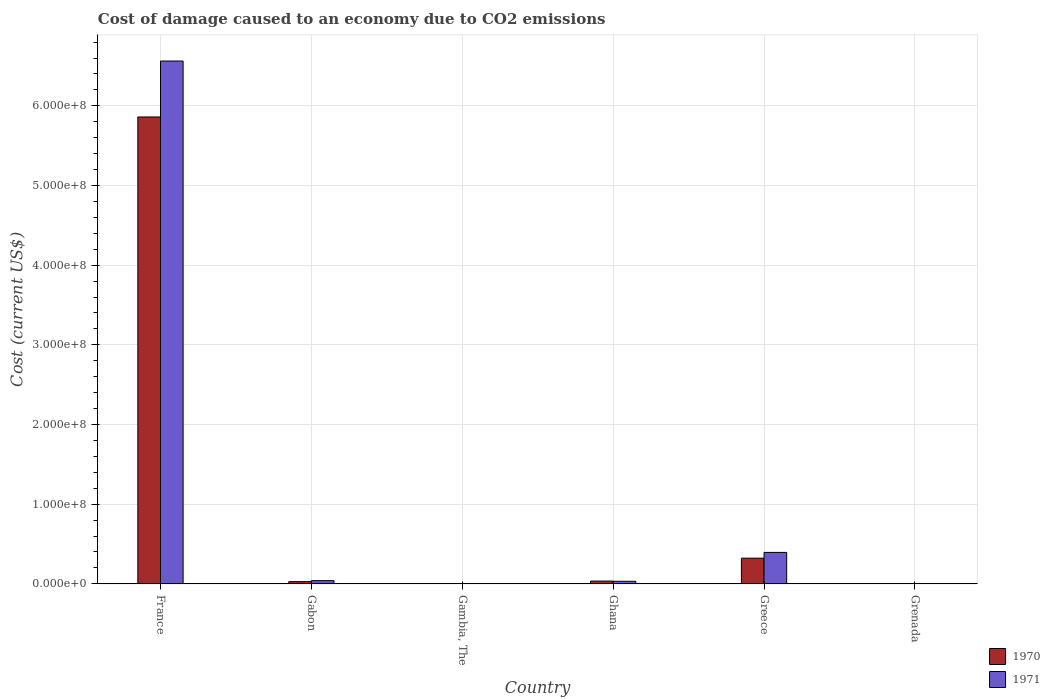How many groups of bars are there?
Provide a succinct answer. 6. Are the number of bars per tick equal to the number of legend labels?
Your answer should be compact. Yes. Are the number of bars on each tick of the X-axis equal?
Provide a succinct answer. Yes. What is the label of the 6th group of bars from the left?
Ensure brevity in your answer.  Grenada. What is the cost of damage caused due to CO2 emissisons in 1971 in France?
Your answer should be compact. 6.56e+08. Across all countries, what is the maximum cost of damage caused due to CO2 emissisons in 1970?
Give a very brief answer. 5.86e+08. Across all countries, what is the minimum cost of damage caused due to CO2 emissisons in 1970?
Your answer should be compact. 5.87e+04. In which country was the cost of damage caused due to CO2 emissisons in 1970 minimum?
Provide a short and direct response. Grenada. What is the total cost of damage caused due to CO2 emissisons in 1971 in the graph?
Provide a succinct answer. 7.03e+08. What is the difference between the cost of damage caused due to CO2 emissisons in 1971 in Greece and that in Grenada?
Provide a short and direct response. 3.94e+07. What is the difference between the cost of damage caused due to CO2 emissisons in 1971 in France and the cost of damage caused due to CO2 emissisons in 1970 in Greece?
Offer a terse response. 6.24e+08. What is the average cost of damage caused due to CO2 emissisons in 1971 per country?
Your answer should be very brief. 1.17e+08. What is the difference between the cost of damage caused due to CO2 emissisons of/in 1970 and cost of damage caused due to CO2 emissisons of/in 1971 in Gabon?
Make the answer very short. -1.26e+06. What is the ratio of the cost of damage caused due to CO2 emissisons in 1970 in Gabon to that in Grenada?
Your response must be concise. 47.33. Is the cost of damage caused due to CO2 emissisons in 1971 in Gabon less than that in Greece?
Ensure brevity in your answer.  Yes. Is the difference between the cost of damage caused due to CO2 emissisons in 1970 in France and Gabon greater than the difference between the cost of damage caused due to CO2 emissisons in 1971 in France and Gabon?
Give a very brief answer. No. What is the difference between the highest and the second highest cost of damage caused due to CO2 emissisons in 1970?
Keep it short and to the point. -5.54e+08. What is the difference between the highest and the lowest cost of damage caused due to CO2 emissisons in 1971?
Provide a succinct answer. 6.56e+08. In how many countries, is the cost of damage caused due to CO2 emissisons in 1971 greater than the average cost of damage caused due to CO2 emissisons in 1971 taken over all countries?
Keep it short and to the point. 1. What does the 1st bar from the left in Gambia, The represents?
Offer a terse response. 1970. What does the 1st bar from the right in Greece represents?
Make the answer very short. 1971. How many bars are there?
Your answer should be compact. 12. How many countries are there in the graph?
Your answer should be very brief. 6. Are the values on the major ticks of Y-axis written in scientific E-notation?
Offer a terse response. Yes. Where does the legend appear in the graph?
Make the answer very short. Bottom right. How many legend labels are there?
Your answer should be very brief. 2. How are the legend labels stacked?
Your response must be concise. Vertical. What is the title of the graph?
Make the answer very short. Cost of damage caused to an economy due to CO2 emissions. Does "1978" appear as one of the legend labels in the graph?
Your response must be concise. No. What is the label or title of the X-axis?
Provide a short and direct response. Country. What is the label or title of the Y-axis?
Provide a succinct answer. Cost (current US$). What is the Cost (current US$) of 1970 in France?
Offer a very short reply. 5.86e+08. What is the Cost (current US$) of 1971 in France?
Your answer should be compact. 6.56e+08. What is the Cost (current US$) in 1970 in Gabon?
Your response must be concise. 2.78e+06. What is the Cost (current US$) in 1971 in Gabon?
Offer a very short reply. 4.04e+06. What is the Cost (current US$) of 1970 in Gambia, The?
Provide a short and direct response. 6.36e+04. What is the Cost (current US$) in 1971 in Gambia, The?
Give a very brief answer. 7.81e+04. What is the Cost (current US$) in 1970 in Ghana?
Keep it short and to the point. 3.50e+06. What is the Cost (current US$) in 1971 in Ghana?
Your answer should be compact. 3.26e+06. What is the Cost (current US$) of 1970 in Greece?
Your response must be concise. 3.23e+07. What is the Cost (current US$) in 1971 in Greece?
Your answer should be compact. 3.95e+07. What is the Cost (current US$) of 1970 in Grenada?
Ensure brevity in your answer.  5.87e+04. What is the Cost (current US$) of 1971 in Grenada?
Your answer should be compact. 6.76e+04. Across all countries, what is the maximum Cost (current US$) of 1970?
Offer a very short reply. 5.86e+08. Across all countries, what is the maximum Cost (current US$) in 1971?
Provide a succinct answer. 6.56e+08. Across all countries, what is the minimum Cost (current US$) in 1970?
Provide a succinct answer. 5.87e+04. Across all countries, what is the minimum Cost (current US$) in 1971?
Offer a terse response. 6.76e+04. What is the total Cost (current US$) of 1970 in the graph?
Give a very brief answer. 6.25e+08. What is the total Cost (current US$) of 1971 in the graph?
Give a very brief answer. 7.03e+08. What is the difference between the Cost (current US$) in 1970 in France and that in Gabon?
Offer a terse response. 5.83e+08. What is the difference between the Cost (current US$) in 1971 in France and that in Gabon?
Offer a very short reply. 6.52e+08. What is the difference between the Cost (current US$) in 1970 in France and that in Gambia, The?
Your answer should be very brief. 5.86e+08. What is the difference between the Cost (current US$) in 1971 in France and that in Gambia, The?
Provide a short and direct response. 6.56e+08. What is the difference between the Cost (current US$) of 1970 in France and that in Ghana?
Ensure brevity in your answer.  5.82e+08. What is the difference between the Cost (current US$) in 1971 in France and that in Ghana?
Provide a succinct answer. 6.53e+08. What is the difference between the Cost (current US$) of 1970 in France and that in Greece?
Offer a very short reply. 5.54e+08. What is the difference between the Cost (current US$) of 1971 in France and that in Greece?
Offer a terse response. 6.17e+08. What is the difference between the Cost (current US$) of 1970 in France and that in Grenada?
Your answer should be very brief. 5.86e+08. What is the difference between the Cost (current US$) in 1971 in France and that in Grenada?
Make the answer very short. 6.56e+08. What is the difference between the Cost (current US$) of 1970 in Gabon and that in Gambia, The?
Your answer should be very brief. 2.72e+06. What is the difference between the Cost (current US$) of 1971 in Gabon and that in Gambia, The?
Provide a succinct answer. 3.96e+06. What is the difference between the Cost (current US$) in 1970 in Gabon and that in Ghana?
Make the answer very short. -7.24e+05. What is the difference between the Cost (current US$) of 1971 in Gabon and that in Ghana?
Keep it short and to the point. 7.81e+05. What is the difference between the Cost (current US$) in 1970 in Gabon and that in Greece?
Make the answer very short. -2.95e+07. What is the difference between the Cost (current US$) of 1971 in Gabon and that in Greece?
Ensure brevity in your answer.  -3.54e+07. What is the difference between the Cost (current US$) in 1970 in Gabon and that in Grenada?
Offer a very short reply. 2.72e+06. What is the difference between the Cost (current US$) of 1971 in Gabon and that in Grenada?
Give a very brief answer. 3.97e+06. What is the difference between the Cost (current US$) of 1970 in Gambia, The and that in Ghana?
Your answer should be very brief. -3.44e+06. What is the difference between the Cost (current US$) in 1971 in Gambia, The and that in Ghana?
Offer a very short reply. -3.18e+06. What is the difference between the Cost (current US$) of 1970 in Gambia, The and that in Greece?
Your answer should be very brief. -3.22e+07. What is the difference between the Cost (current US$) of 1971 in Gambia, The and that in Greece?
Give a very brief answer. -3.94e+07. What is the difference between the Cost (current US$) of 1970 in Gambia, The and that in Grenada?
Give a very brief answer. 4894.68. What is the difference between the Cost (current US$) in 1971 in Gambia, The and that in Grenada?
Your answer should be compact. 1.04e+04. What is the difference between the Cost (current US$) of 1970 in Ghana and that in Greece?
Your answer should be very brief. -2.88e+07. What is the difference between the Cost (current US$) of 1971 in Ghana and that in Greece?
Give a very brief answer. -3.62e+07. What is the difference between the Cost (current US$) in 1970 in Ghana and that in Grenada?
Give a very brief answer. 3.45e+06. What is the difference between the Cost (current US$) in 1971 in Ghana and that in Grenada?
Offer a very short reply. 3.19e+06. What is the difference between the Cost (current US$) in 1970 in Greece and that in Grenada?
Your answer should be compact. 3.22e+07. What is the difference between the Cost (current US$) in 1971 in Greece and that in Grenada?
Your answer should be compact. 3.94e+07. What is the difference between the Cost (current US$) in 1970 in France and the Cost (current US$) in 1971 in Gabon?
Provide a short and direct response. 5.82e+08. What is the difference between the Cost (current US$) of 1970 in France and the Cost (current US$) of 1971 in Gambia, The?
Provide a succinct answer. 5.86e+08. What is the difference between the Cost (current US$) of 1970 in France and the Cost (current US$) of 1971 in Ghana?
Give a very brief answer. 5.83e+08. What is the difference between the Cost (current US$) in 1970 in France and the Cost (current US$) in 1971 in Greece?
Make the answer very short. 5.47e+08. What is the difference between the Cost (current US$) of 1970 in France and the Cost (current US$) of 1971 in Grenada?
Make the answer very short. 5.86e+08. What is the difference between the Cost (current US$) in 1970 in Gabon and the Cost (current US$) in 1971 in Gambia, The?
Ensure brevity in your answer.  2.70e+06. What is the difference between the Cost (current US$) in 1970 in Gabon and the Cost (current US$) in 1971 in Ghana?
Provide a succinct answer. -4.77e+05. What is the difference between the Cost (current US$) in 1970 in Gabon and the Cost (current US$) in 1971 in Greece?
Offer a terse response. -3.67e+07. What is the difference between the Cost (current US$) in 1970 in Gabon and the Cost (current US$) in 1971 in Grenada?
Give a very brief answer. 2.71e+06. What is the difference between the Cost (current US$) of 1970 in Gambia, The and the Cost (current US$) of 1971 in Ghana?
Make the answer very short. -3.19e+06. What is the difference between the Cost (current US$) of 1970 in Gambia, The and the Cost (current US$) of 1971 in Greece?
Keep it short and to the point. -3.94e+07. What is the difference between the Cost (current US$) of 1970 in Gambia, The and the Cost (current US$) of 1971 in Grenada?
Make the answer very short. -4016.81. What is the difference between the Cost (current US$) of 1970 in Ghana and the Cost (current US$) of 1971 in Greece?
Make the answer very short. -3.60e+07. What is the difference between the Cost (current US$) in 1970 in Ghana and the Cost (current US$) in 1971 in Grenada?
Your response must be concise. 3.44e+06. What is the difference between the Cost (current US$) of 1970 in Greece and the Cost (current US$) of 1971 in Grenada?
Offer a very short reply. 3.22e+07. What is the average Cost (current US$) of 1970 per country?
Offer a terse response. 1.04e+08. What is the average Cost (current US$) of 1971 per country?
Offer a very short reply. 1.17e+08. What is the difference between the Cost (current US$) in 1970 and Cost (current US$) in 1971 in France?
Keep it short and to the point. -7.02e+07. What is the difference between the Cost (current US$) of 1970 and Cost (current US$) of 1971 in Gabon?
Offer a terse response. -1.26e+06. What is the difference between the Cost (current US$) in 1970 and Cost (current US$) in 1971 in Gambia, The?
Your response must be concise. -1.44e+04. What is the difference between the Cost (current US$) in 1970 and Cost (current US$) in 1971 in Ghana?
Give a very brief answer. 2.47e+05. What is the difference between the Cost (current US$) in 1970 and Cost (current US$) in 1971 in Greece?
Provide a succinct answer. -7.21e+06. What is the difference between the Cost (current US$) in 1970 and Cost (current US$) in 1971 in Grenada?
Your answer should be very brief. -8911.49. What is the ratio of the Cost (current US$) of 1970 in France to that in Gabon?
Your answer should be compact. 210.77. What is the ratio of the Cost (current US$) of 1971 in France to that in Gabon?
Offer a terse response. 162.51. What is the ratio of the Cost (current US$) in 1970 in France to that in Gambia, The?
Keep it short and to the point. 9209.23. What is the ratio of the Cost (current US$) in 1971 in France to that in Gambia, The?
Make the answer very short. 8407.13. What is the ratio of the Cost (current US$) in 1970 in France to that in Ghana?
Provide a short and direct response. 167.21. What is the ratio of the Cost (current US$) of 1971 in France to that in Ghana?
Ensure brevity in your answer.  201.45. What is the ratio of the Cost (current US$) in 1970 in France to that in Greece?
Give a very brief answer. 18.17. What is the ratio of the Cost (current US$) of 1971 in France to that in Greece?
Your response must be concise. 16.63. What is the ratio of the Cost (current US$) of 1970 in France to that in Grenada?
Your answer should be very brief. 9976.67. What is the ratio of the Cost (current US$) of 1971 in France to that in Grenada?
Provide a succinct answer. 9700.54. What is the ratio of the Cost (current US$) in 1970 in Gabon to that in Gambia, The?
Make the answer very short. 43.69. What is the ratio of the Cost (current US$) in 1971 in Gabon to that in Gambia, The?
Your response must be concise. 51.73. What is the ratio of the Cost (current US$) of 1970 in Gabon to that in Ghana?
Offer a terse response. 0.79. What is the ratio of the Cost (current US$) in 1971 in Gabon to that in Ghana?
Your answer should be compact. 1.24. What is the ratio of the Cost (current US$) in 1970 in Gabon to that in Greece?
Keep it short and to the point. 0.09. What is the ratio of the Cost (current US$) in 1971 in Gabon to that in Greece?
Make the answer very short. 0.1. What is the ratio of the Cost (current US$) in 1970 in Gabon to that in Grenada?
Your answer should be compact. 47.33. What is the ratio of the Cost (current US$) of 1971 in Gabon to that in Grenada?
Provide a succinct answer. 59.69. What is the ratio of the Cost (current US$) in 1970 in Gambia, The to that in Ghana?
Provide a succinct answer. 0.02. What is the ratio of the Cost (current US$) in 1971 in Gambia, The to that in Ghana?
Ensure brevity in your answer.  0.02. What is the ratio of the Cost (current US$) in 1970 in Gambia, The to that in Greece?
Ensure brevity in your answer.  0. What is the ratio of the Cost (current US$) of 1971 in Gambia, The to that in Greece?
Offer a very short reply. 0. What is the ratio of the Cost (current US$) of 1970 in Gambia, The to that in Grenada?
Your answer should be compact. 1.08. What is the ratio of the Cost (current US$) of 1971 in Gambia, The to that in Grenada?
Your response must be concise. 1.15. What is the ratio of the Cost (current US$) of 1970 in Ghana to that in Greece?
Offer a terse response. 0.11. What is the ratio of the Cost (current US$) in 1971 in Ghana to that in Greece?
Make the answer very short. 0.08. What is the ratio of the Cost (current US$) of 1970 in Ghana to that in Grenada?
Provide a succinct answer. 59.67. What is the ratio of the Cost (current US$) in 1971 in Ghana to that in Grenada?
Ensure brevity in your answer.  48.15. What is the ratio of the Cost (current US$) of 1970 in Greece to that in Grenada?
Your response must be concise. 549.17. What is the ratio of the Cost (current US$) of 1971 in Greece to that in Grenada?
Offer a terse response. 583.46. What is the difference between the highest and the second highest Cost (current US$) in 1970?
Provide a succinct answer. 5.54e+08. What is the difference between the highest and the second highest Cost (current US$) of 1971?
Keep it short and to the point. 6.17e+08. What is the difference between the highest and the lowest Cost (current US$) of 1970?
Offer a terse response. 5.86e+08. What is the difference between the highest and the lowest Cost (current US$) of 1971?
Keep it short and to the point. 6.56e+08. 